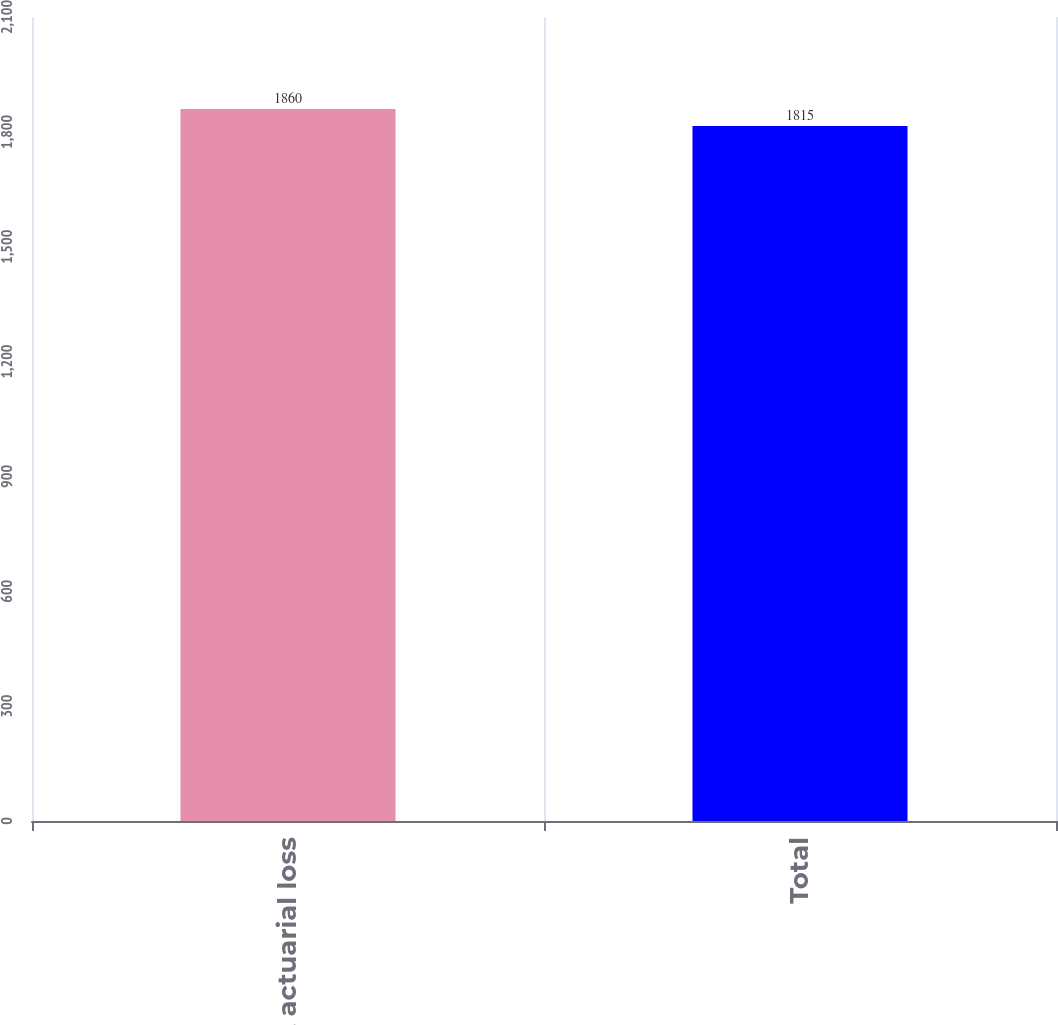Convert chart to OTSL. <chart><loc_0><loc_0><loc_500><loc_500><bar_chart><fcel>Net actuarial loss<fcel>Total<nl><fcel>1860<fcel>1815<nl></chart> 